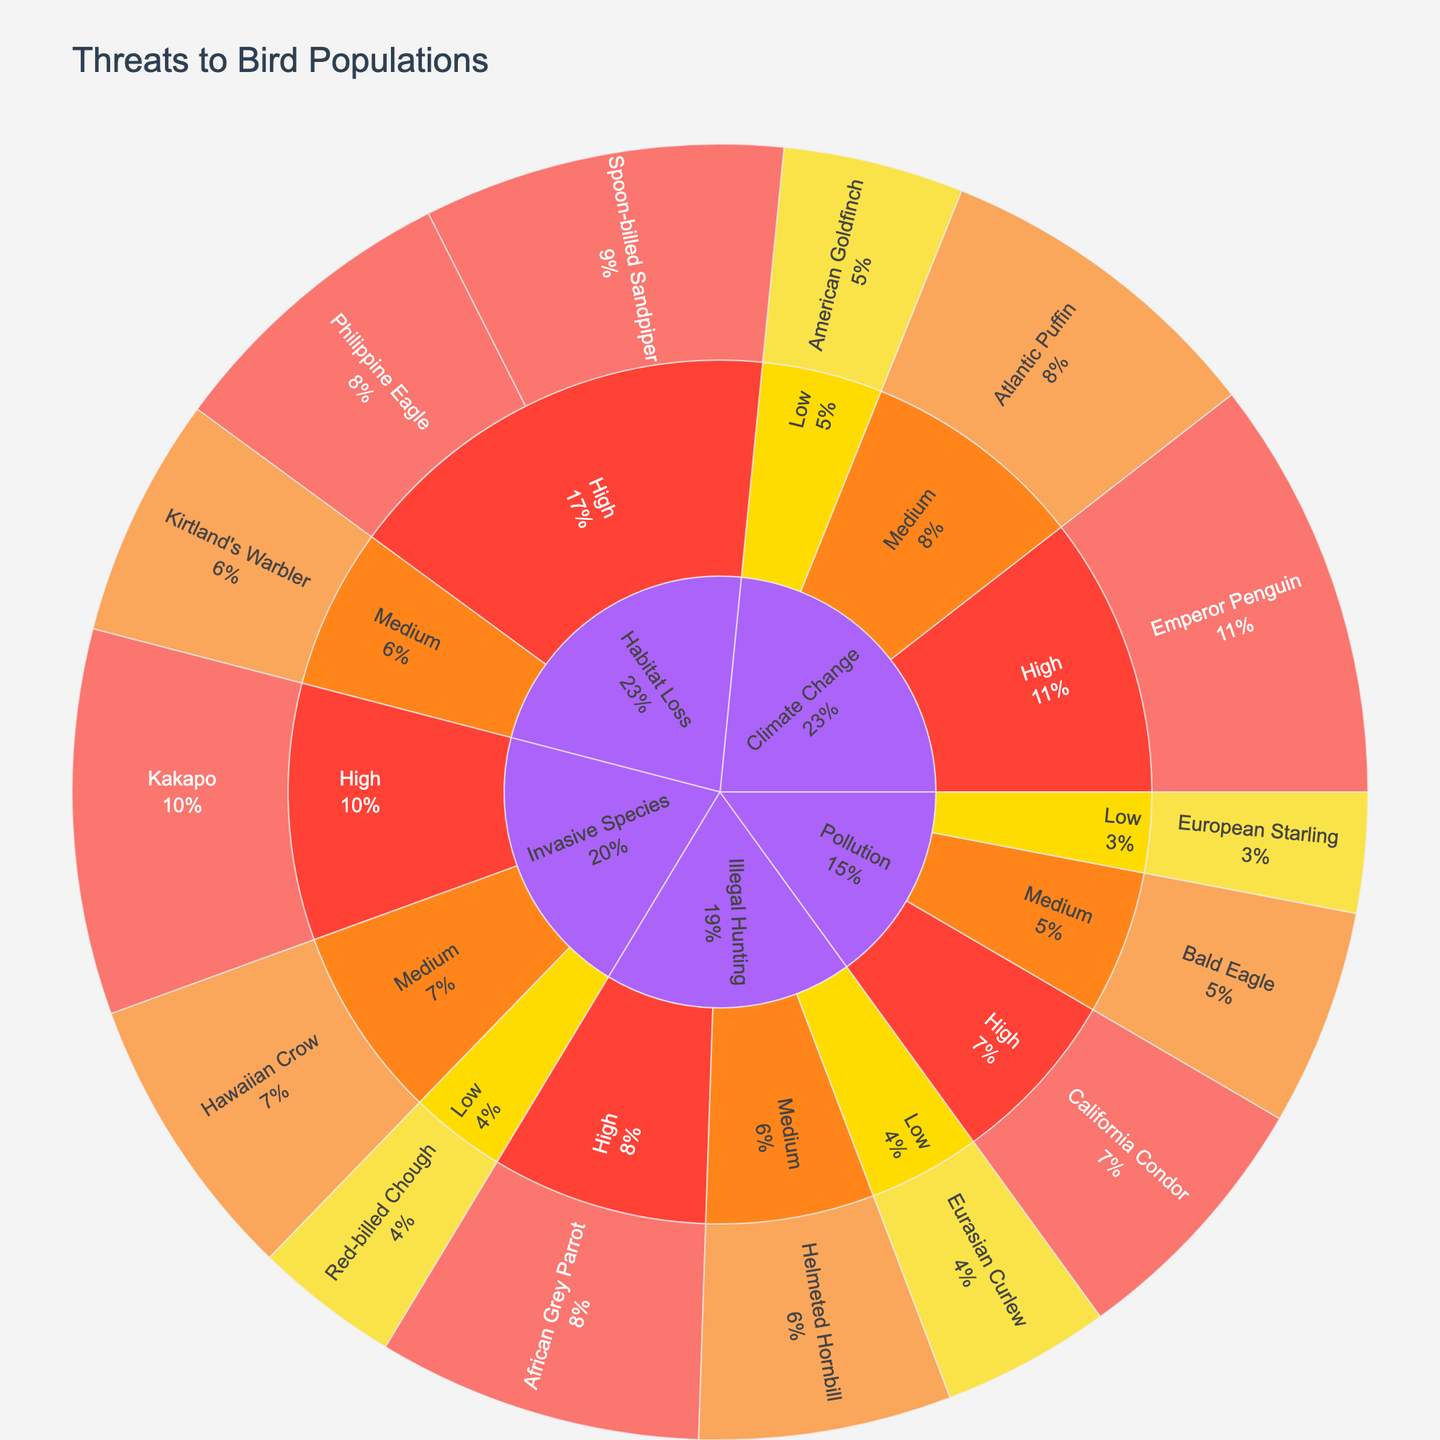What's the primary source of threat to bird populations? The largest color area indicates the primary source of threat. 'Habitat Loss' dominates the plot, meaning it's the primary source.
Answer: Habitat Loss Which species is most affected by Climate Change? Navigate through 'Climate Change' to the highest value in the plot, which is associated with 'Emperor Penguin' (35).
Answer: Emperor Penguin How does the number of birds affected by Illegal Hunting compare to those affected by Invasive Species? Sum all values under 'Illegal Hunting' (27+21+14 = 62) and 'Invasive Species' (32+24+12 = 68). Compare the two totals.
Answer: Fewer Which threat has the least impact on American Goldfinch? Navigate to 'Climate Change', 'Low', and find 'American Goldfinch' with a value of 15. Within 'Climate Change', compare it to other values (35 and 28).
Answer: Climate Change What percentage of the affected bird population is accounted for by the Kakapo? Find 'Kakapo' under 'Invasive Species' with a value of 32. Calculate its percentage of the total (sum of all values, 303): (32/303) * 100.
Answer: Approximately 10.56% Compare the severity of threats to Kirtland's Warbler and Red-billed Chough. Compare their severities under 'Habitat Loss' and 'Invasive Species', respectively. Kirtland's Warbler is Medium, Red-billed Chough is Low.
Answer: More severe for Kirtland's Warbler What portion of threats to bird populations is due to Pollution? Sum values under 'Pollution' (22+18+10 = 50) and calculate its percentage of the total (303): (50/303) * 100.
Answer: Approximately 16.5% How many species are affected by High severity threats? Count all species under 'High' severity across all sources.
Answer: 6 